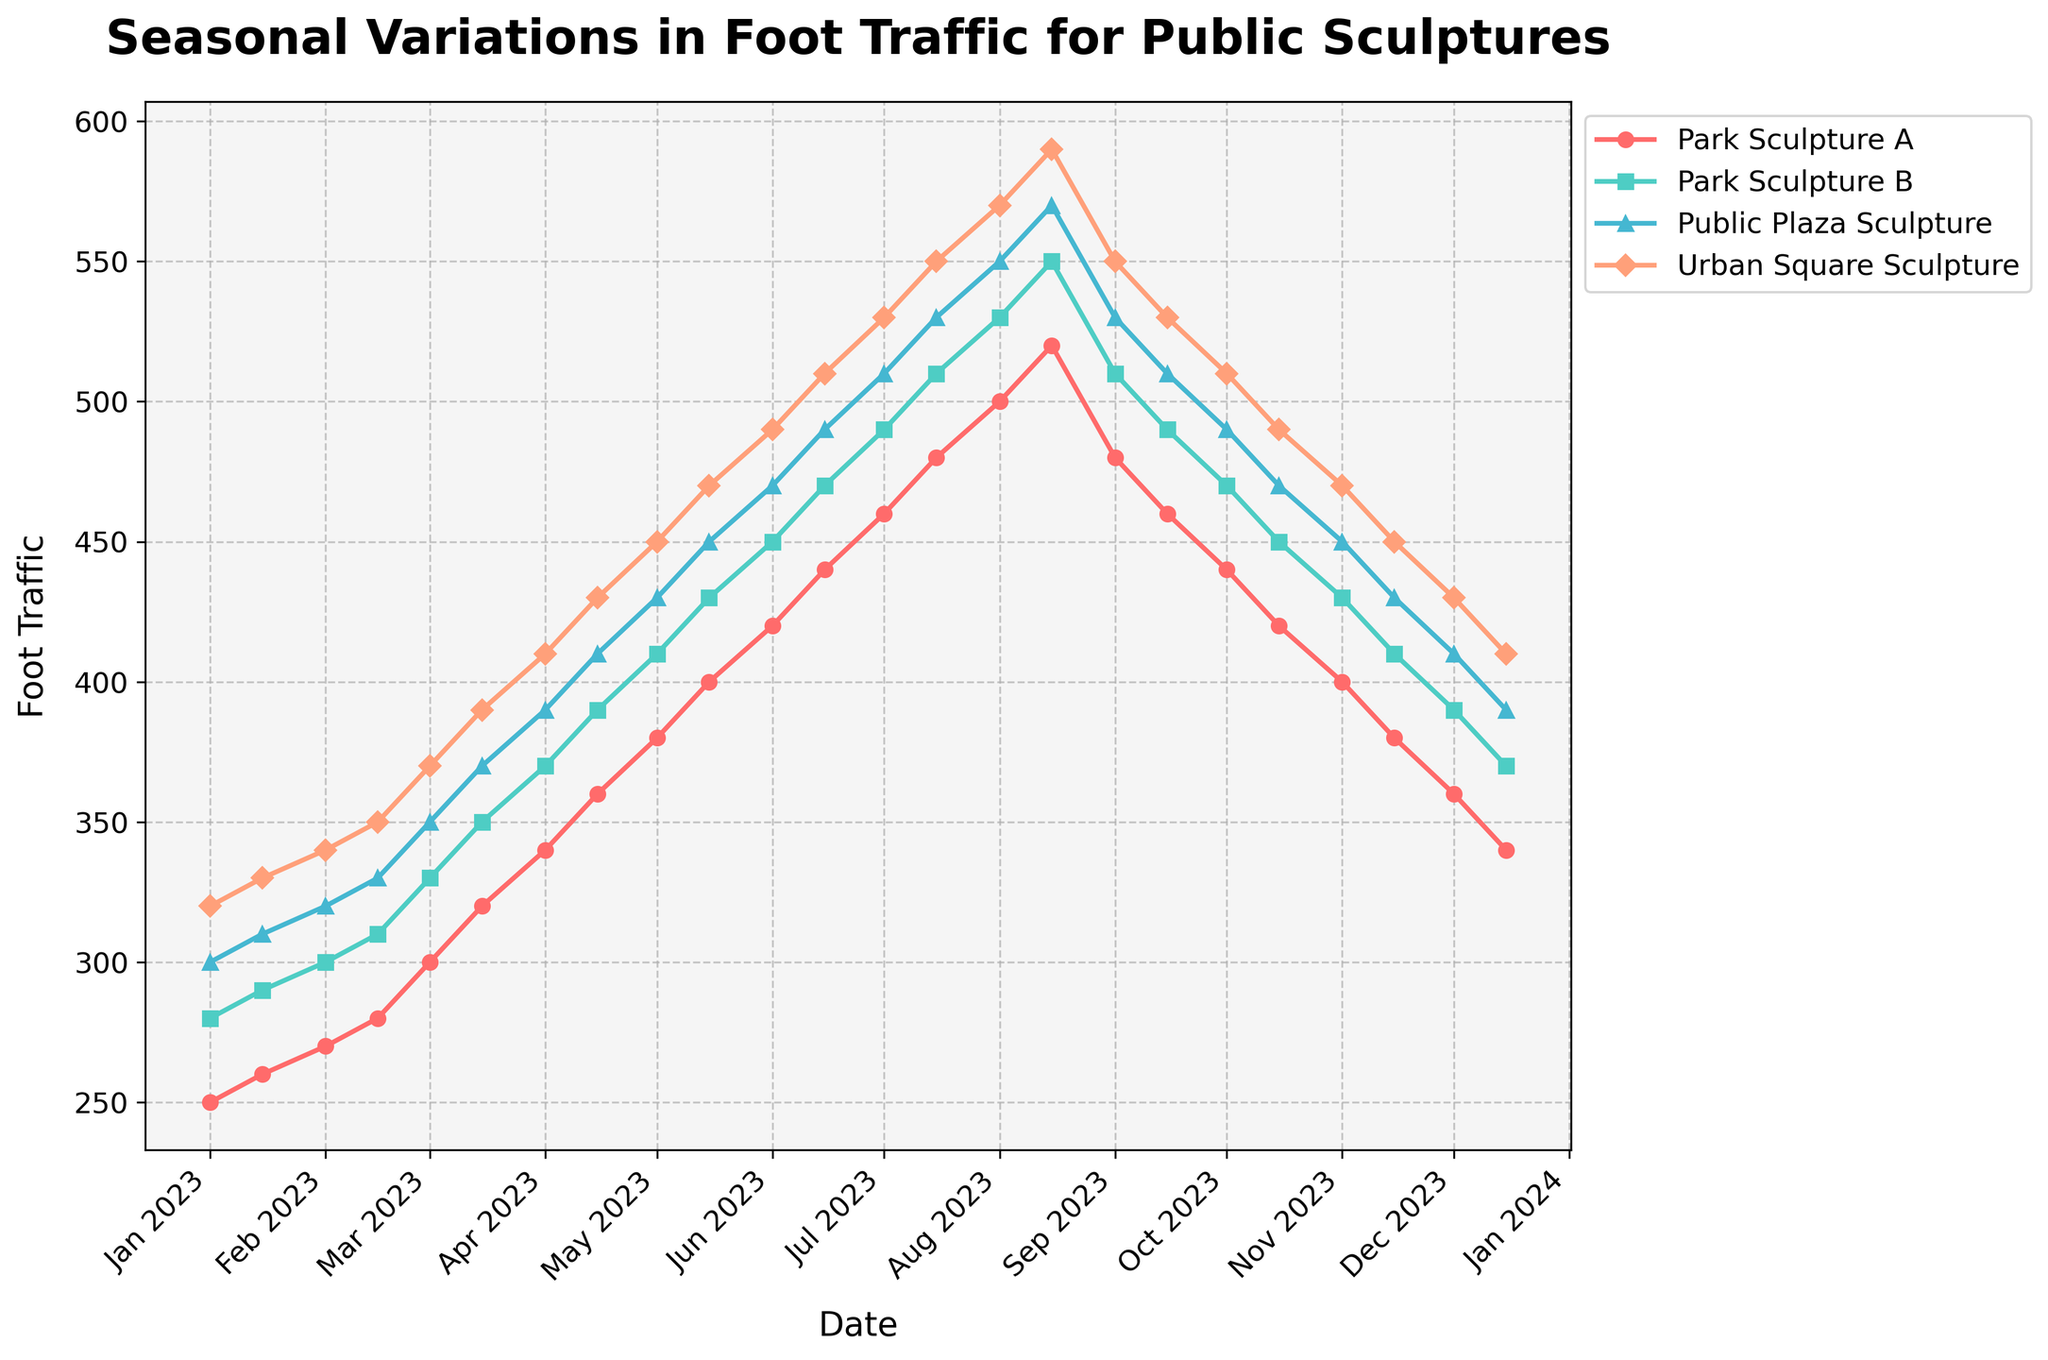What is the title of the plot? The title of the plot is displayed at the top center of the figure in bold font. It reads "Seasonal Variations in Foot Traffic for Public Sculptures".
Answer: Seasonal Variations in Foot Traffic for Public Sculptures What is the color of the plot line for Park Sculpture A? The color of the plot line for Park Sculpture A is indicated in the figure. It is a shade of red.
Answer: Red Around which date did foot traffic at Urban Square Sculpture peak? Referring to the figure, the peak foot traffic for Urban Square Sculpture is observed around the middle of August 2023.
Answer: Mid-August 2023 Between which months does foot traffic seem to decline? Observing the plot, foot traffic appears to decline from September to December 2023 for all sculptures.
Answer: September to December 2023 What is the approximate foot traffic at Public Plaza Sculpture in June 2023? By locating June 2023 on the x-axis and following it up to the Public Plaza Sculpture line, the foot traffic is approximately 470.
Answer: 470 How many data points are plotted for each sculpture? Each sculpture has data points starting from January 1, 2023, to December 15, 2023. There are 24 data points for each sculpture.
Answer: 24 Which sculpture shows the highest increase in foot traffic from January to August 2023? By measuring the increase from January to August 2023, the Urban Square Sculpture shoes the highest foot traffic increase from 320 to 590, a difference of 270.
Answer: Urban Square Sculpture What is the difference in foot traffic between May 1 and May 15 for Park Sculpture B? The foot traffic for Park Sculpture B on May 1 is 410 and on May 15 is 430. The difference is 430 - 410 = 20.
Answer: 20 By how much does foot traffic drop for Public Plaza Sculpture from September 1 to October 1, 2023? The foot traffic for Public Plaza Sculpture on September 1 is 530 and on October 1 is 490. The drop is 530 - 490 = 40.
Answer: 40 What trend do you observe in foot traffic during the summer months (June to September) for all sculptures? Observing the figure, there is an increase in foot traffic during the summer months (June to September) for all sculptures, followed by a decline starting around September.
Answer: Increase followed by decline 